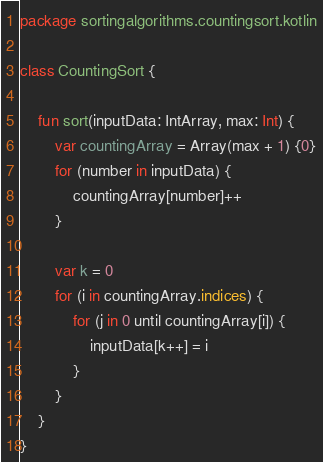Convert code to text. <code><loc_0><loc_0><loc_500><loc_500><_Kotlin_>package sortingalgorithms.countingsort.kotlin

class CountingSort {

    fun sort(inputData: IntArray, max: Int) {
        var countingArray = Array(max + 1) {0}
        for (number in inputData) {
            countingArray[number]++
        }

        var k = 0
        for (i in countingArray.indices) {
            for (j in 0 until countingArray[i]) {
                inputData[k++] = i
            }
        }
    }
}</code> 